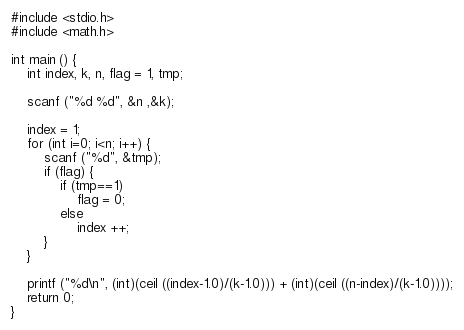<code> <loc_0><loc_0><loc_500><loc_500><_C_>#include <stdio.h>
#include <math.h>

int main () {
	int index, k, n, flag = 1, tmp;

	scanf ("%d %d", &n ,&k);

	index = 1;
	for (int i=0; i<n; i++) {
		scanf ("%d", &tmp);
		if (flag) {
			if (tmp==1)
				flag = 0;
			else
				index ++;
		}
	}

	printf ("%d\n", (int)(ceil ((index-1.0)/(k-1.0))) + (int)(ceil ((n-index)/(k-1.0))));
	return 0;
}
</code> 